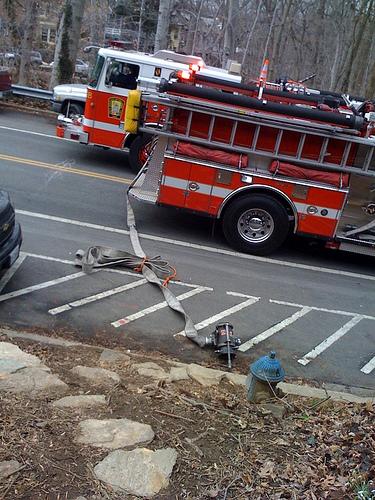How many white lines do you see on the road?
Write a very short answer. 10. Is there fire in the forest?
Quick response, please. Yes. What vehicle is this?
Write a very short answer. Fire truck. 